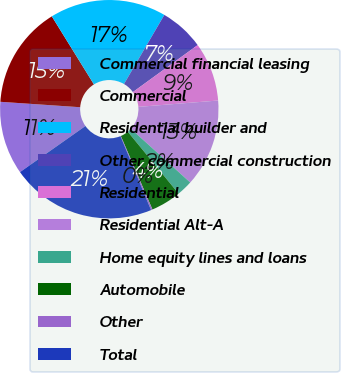Convert chart. <chart><loc_0><loc_0><loc_500><loc_500><pie_chart><fcel>Commercial financial leasing<fcel>Commercial<fcel>Residential builder and<fcel>Other commercial construction<fcel>Residential<fcel>Residential Alt-A<fcel>Home equity lines and loans<fcel>Automobile<fcel>Other<fcel>Total<nl><fcel>10.85%<fcel>15.1%<fcel>17.23%<fcel>6.6%<fcel>8.72%<fcel>12.98%<fcel>2.35%<fcel>4.47%<fcel>0.22%<fcel>21.48%<nl></chart> 